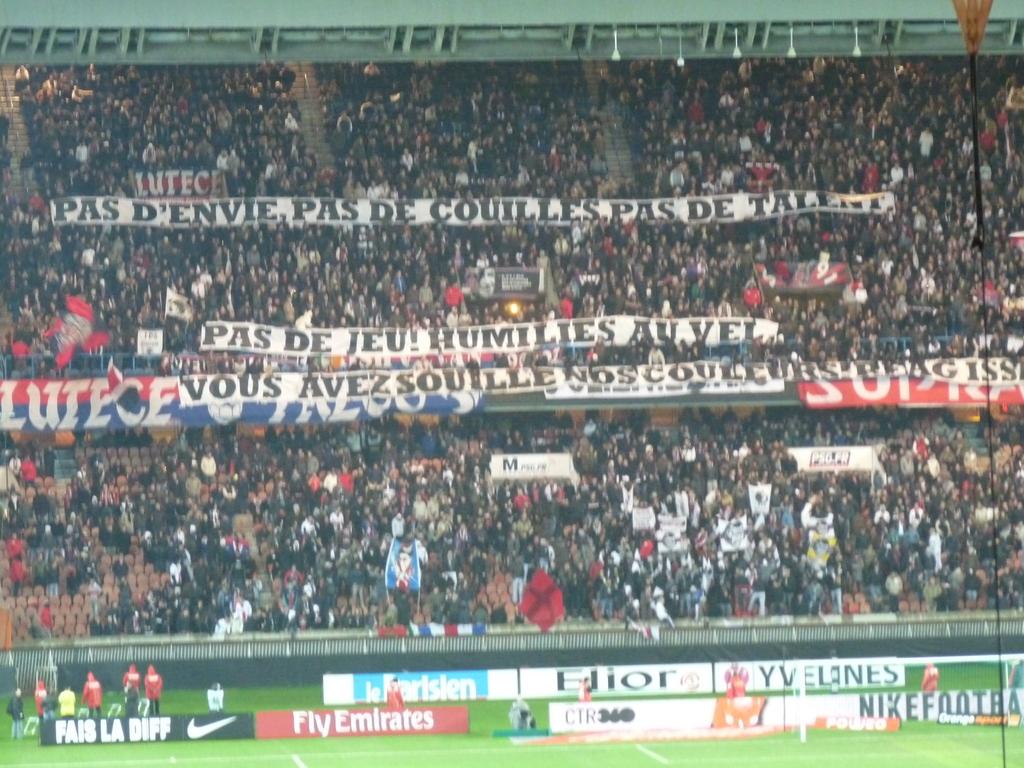What does the nike banner say?
Your answer should be compact. Fais la diff. Is this place crowded?
Ensure brevity in your answer.  Answering does not require reading text in the image. 